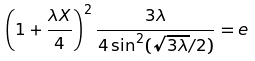<formula> <loc_0><loc_0><loc_500><loc_500>\left ( 1 + \frac { \lambda X } { 4 } \right ) ^ { 2 } \frac { 3 \lambda } { 4 \sin ^ { 2 } ( \sqrt { 3 \lambda } / 2 ) } = { e }</formula> 